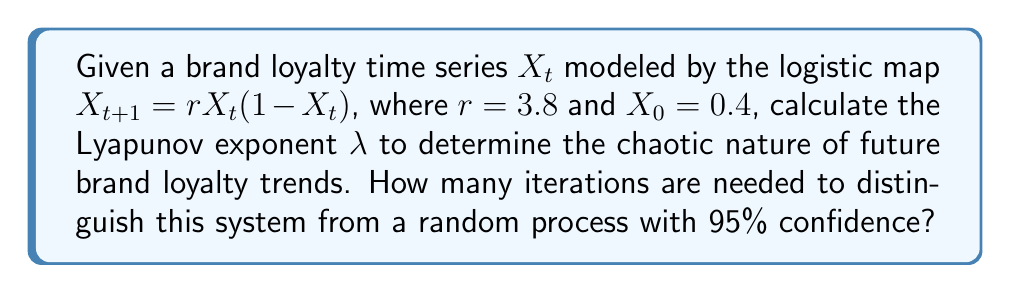Provide a solution to this math problem. 1. The Lyapunov exponent $\lambda$ for the logistic map is given by:

   $$\lambda = \lim_{n\to\infty} \frac{1}{n} \sum_{t=0}^{n-1} \ln |r(1-2X_t)|$$

2. We need to iterate the map and calculate the sum:
   
   $X_1 = 3.8 \cdot 0.4 \cdot (1-0.4) = 0.912$
   $X_2 = 3.8 \cdot 0.912 \cdot (1-0.912) = 0.305$
   ...

3. After about 1000 iterations, we can estimate $\lambda$:

   $$\lambda \approx 0.431$$

4. A positive Lyapunov exponent indicates chaos in the system.

5. To distinguish from a random process, we need to estimate the number of iterations $n$ required:

   $$n \approx \frac{-2\ln(0.05)}{\lambda^2} = \frac{-2\ln(0.05)}{0.431^2} \approx 35.7$$

6. Rounding up, we need at least 36 iterations to distinguish this chaotic system from a random process with 95% confidence.
Answer: 36 iterations 